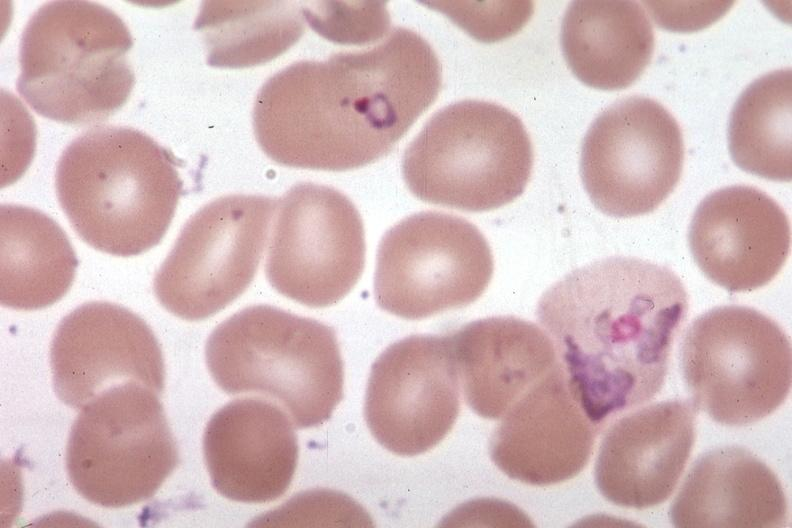does glomerulosa show oil wrights very good?
Answer the question using a single word or phrase. No 